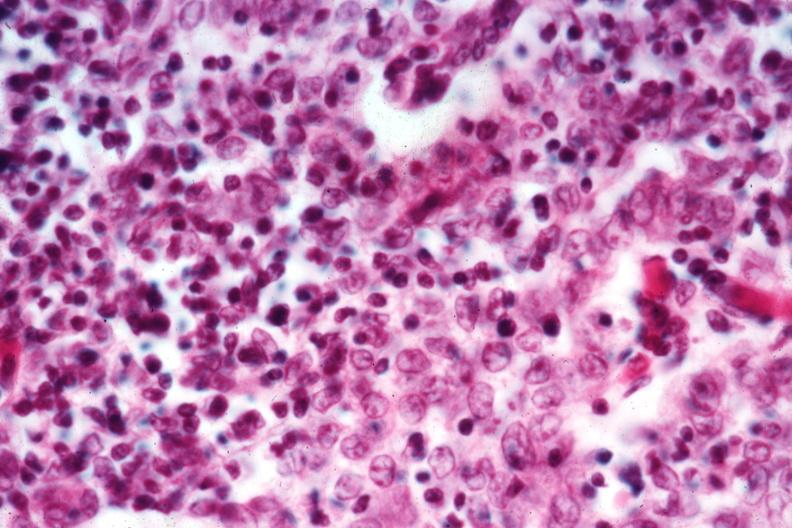s anencephaly and bilateral cleft palate present?
Answer the question using a single word or phrase. No 